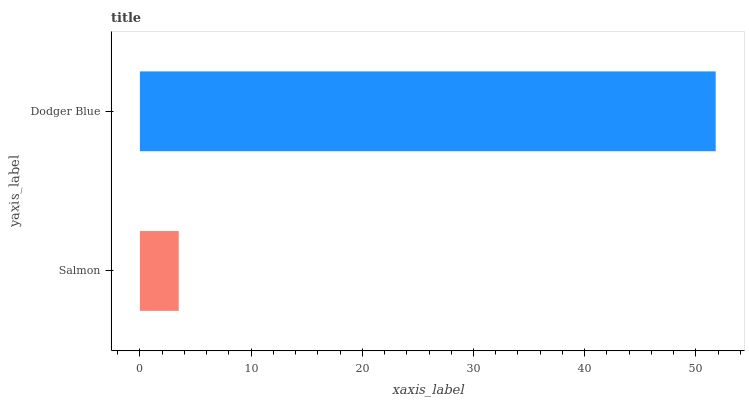Is Salmon the minimum?
Answer yes or no. Yes. Is Dodger Blue the maximum?
Answer yes or no. Yes. Is Dodger Blue the minimum?
Answer yes or no. No. Is Dodger Blue greater than Salmon?
Answer yes or no. Yes. Is Salmon less than Dodger Blue?
Answer yes or no. Yes. Is Salmon greater than Dodger Blue?
Answer yes or no. No. Is Dodger Blue less than Salmon?
Answer yes or no. No. Is Dodger Blue the high median?
Answer yes or no. Yes. Is Salmon the low median?
Answer yes or no. Yes. Is Salmon the high median?
Answer yes or no. No. Is Dodger Blue the low median?
Answer yes or no. No. 